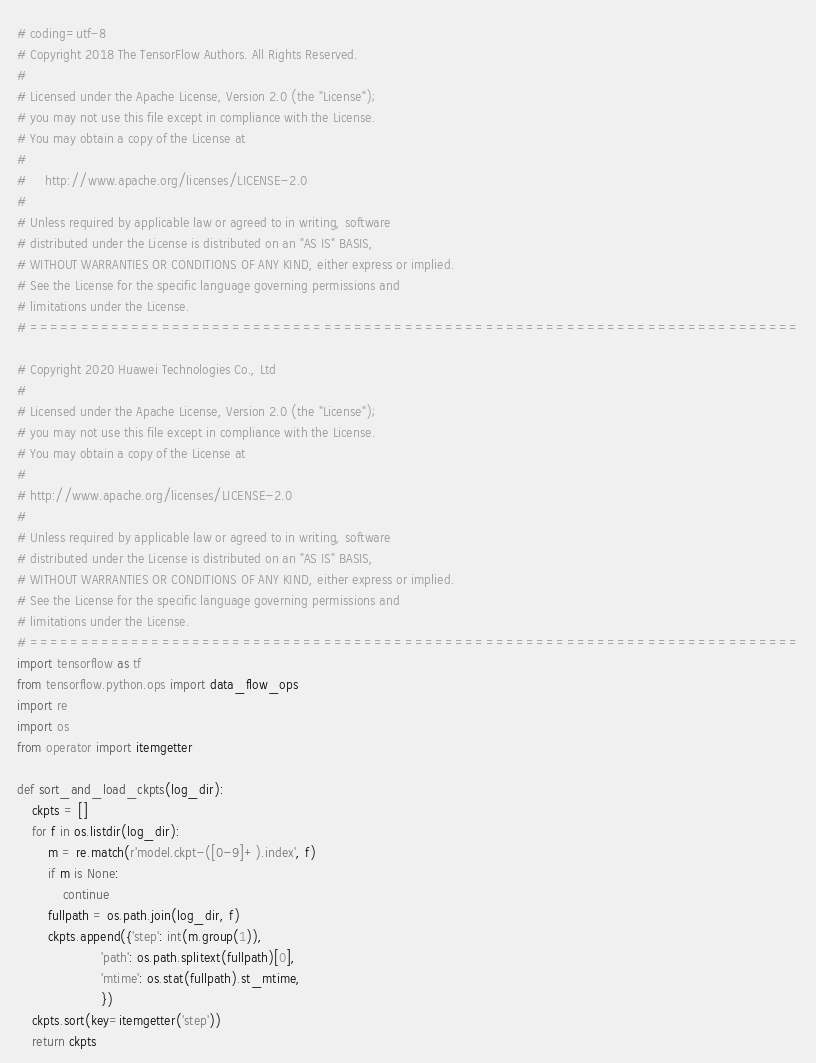<code> <loc_0><loc_0><loc_500><loc_500><_Python_># coding=utf-8
# Copyright 2018 The TensorFlow Authors. All Rights Reserved.
#
# Licensed under the Apache License, Version 2.0 (the "License");
# you may not use this file except in compliance with the License.
# You may obtain a copy of the License at
#
#     http://www.apache.org/licenses/LICENSE-2.0
#
# Unless required by applicable law or agreed to in writing, software
# distributed under the License is distributed on an "AS IS" BASIS,
# WITHOUT WARRANTIES OR CONDITIONS OF ANY KIND, either express or implied.
# See the License for the specific language governing permissions and
# limitations under the License.
# ============================================================================

# Copyright 2020 Huawei Technologies Co., Ltd
#
# Licensed under the Apache License, Version 2.0 (the "License");
# you may not use this file except in compliance with the License.
# You may obtain a copy of the License at
#
# http://www.apache.org/licenses/LICENSE-2.0
#
# Unless required by applicable law or agreed to in writing, software
# distributed under the License is distributed on an "AS IS" BASIS,
# WITHOUT WARRANTIES OR CONDITIONS OF ANY KIND, either express or implied.
# See the License for the specific language governing permissions and
# limitations under the License.
# ============================================================================
import tensorflow as tf
from tensorflow.python.ops import data_flow_ops
import re
import os
from operator import itemgetter

def sort_and_load_ckpts(log_dir):
    ckpts = []
    for f in os.listdir(log_dir):
        m = re.match(r'model.ckpt-([0-9]+).index', f)
        if m is None:
            continue
        fullpath = os.path.join(log_dir, f)
        ckpts.append({'step': int(m.group(1)),
                      'path': os.path.splitext(fullpath)[0],
                      'mtime': os.stat(fullpath).st_mtime,
                      })
    ckpts.sort(key=itemgetter('step'))
    return ckpts

</code> 